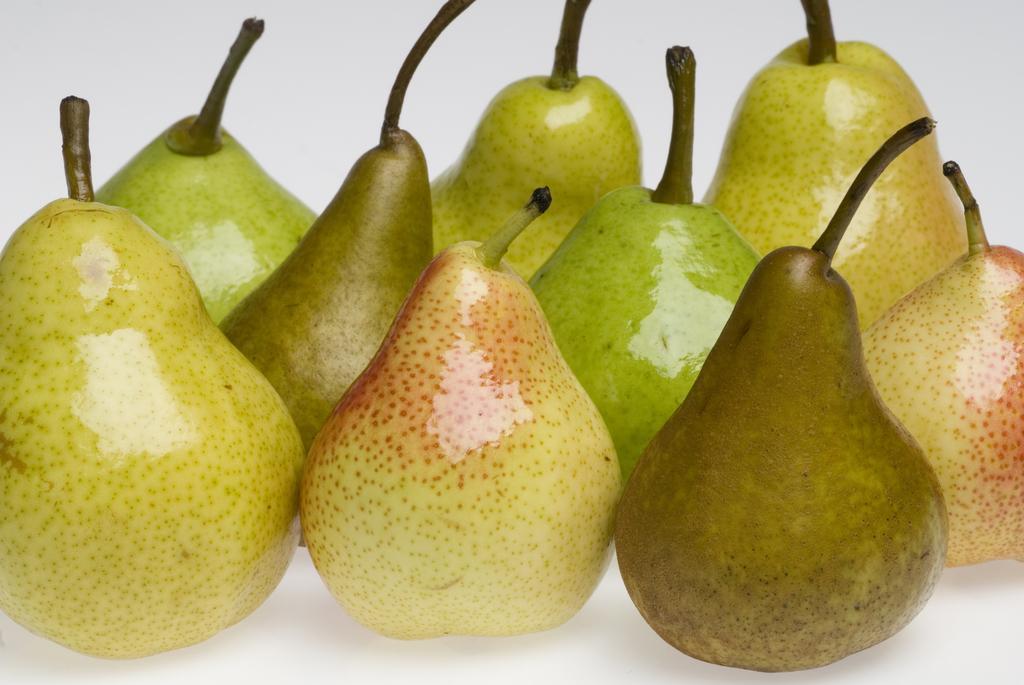Can you describe this image briefly? In this image we can see few fruits looks like peas and a white background. 